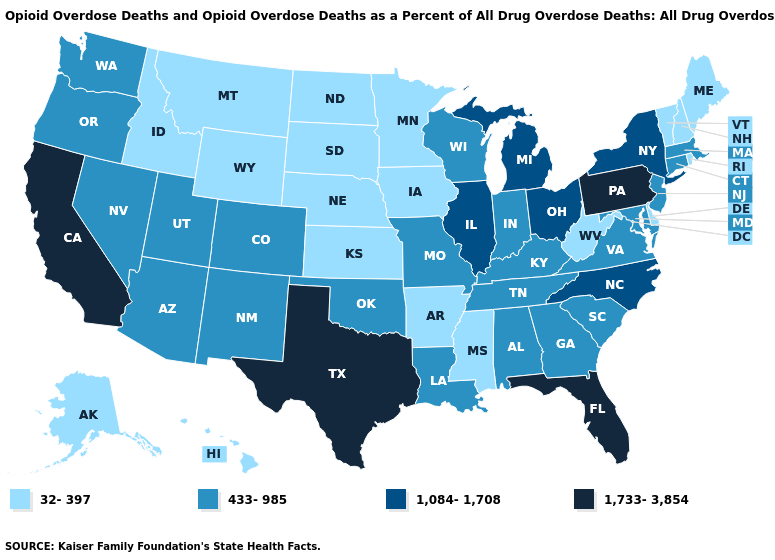What is the value of Nebraska?
Give a very brief answer. 32-397. Does Nebraska have a lower value than Montana?
Be succinct. No. Does South Dakota have the same value as Montana?
Short answer required. Yes. How many symbols are there in the legend?
Answer briefly. 4. Among the states that border Arkansas , does Mississippi have the lowest value?
Short answer required. Yes. Which states have the lowest value in the USA?
Short answer required. Alaska, Arkansas, Delaware, Hawaii, Idaho, Iowa, Kansas, Maine, Minnesota, Mississippi, Montana, Nebraska, New Hampshire, North Dakota, Rhode Island, South Dakota, Vermont, West Virginia, Wyoming. Name the states that have a value in the range 32-397?
Keep it brief. Alaska, Arkansas, Delaware, Hawaii, Idaho, Iowa, Kansas, Maine, Minnesota, Mississippi, Montana, Nebraska, New Hampshire, North Dakota, Rhode Island, South Dakota, Vermont, West Virginia, Wyoming. Among the states that border Tennessee , which have the highest value?
Answer briefly. North Carolina. Which states have the lowest value in the USA?
Give a very brief answer. Alaska, Arkansas, Delaware, Hawaii, Idaho, Iowa, Kansas, Maine, Minnesota, Mississippi, Montana, Nebraska, New Hampshire, North Dakota, Rhode Island, South Dakota, Vermont, West Virginia, Wyoming. Does South Dakota have the highest value in the MidWest?
Quick response, please. No. What is the value of Virginia?
Give a very brief answer. 433-985. Name the states that have a value in the range 433-985?
Give a very brief answer. Alabama, Arizona, Colorado, Connecticut, Georgia, Indiana, Kentucky, Louisiana, Maryland, Massachusetts, Missouri, Nevada, New Jersey, New Mexico, Oklahoma, Oregon, South Carolina, Tennessee, Utah, Virginia, Washington, Wisconsin. Among the states that border Montana , which have the highest value?
Write a very short answer. Idaho, North Dakota, South Dakota, Wyoming. Is the legend a continuous bar?
Write a very short answer. No. Does the first symbol in the legend represent the smallest category?
Give a very brief answer. Yes. 